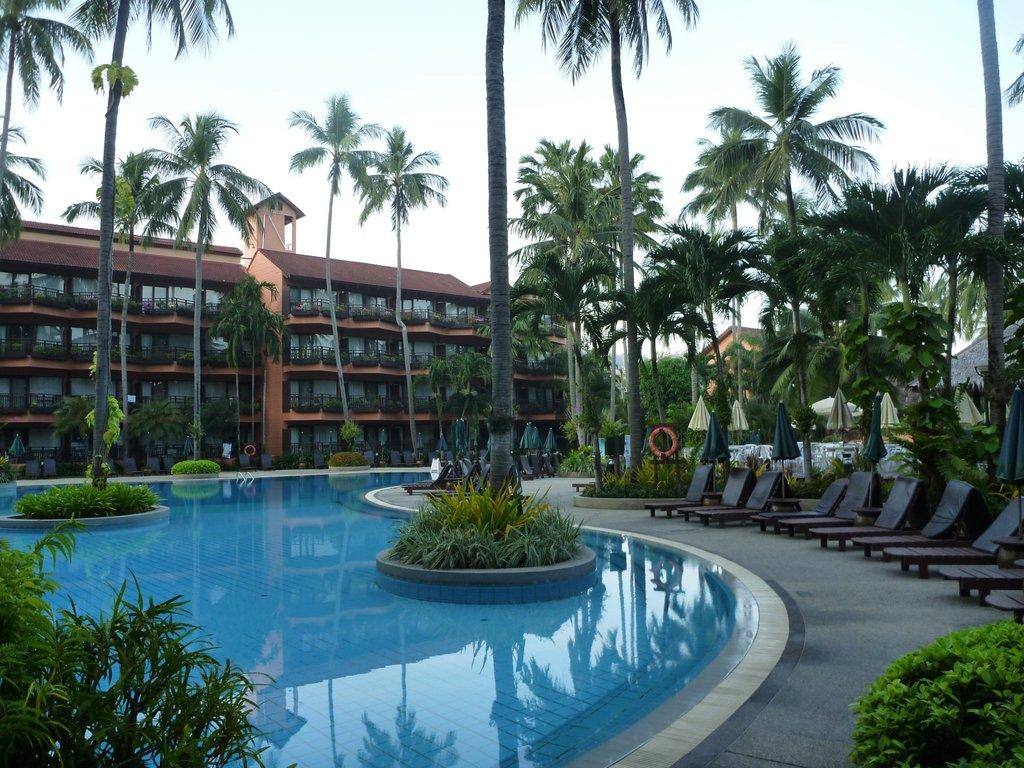What type of surface can be seen in the image? Ground is visible in the image. What type of vegetation is present in the image? There are green plants and trees in the image. What is the other natural element visible in the image? There is water visible in the image. What type of furniture is in the image? There are chairs in the image. What type of accessory is in the image for providing shade? There are umbrellas in the image. What can be seen in the background of the image? There are buildings and the sky visible in the background of the image. How does the pipe increase the efficiency of the bit in the image? There is no pipe or bit present in the image. 